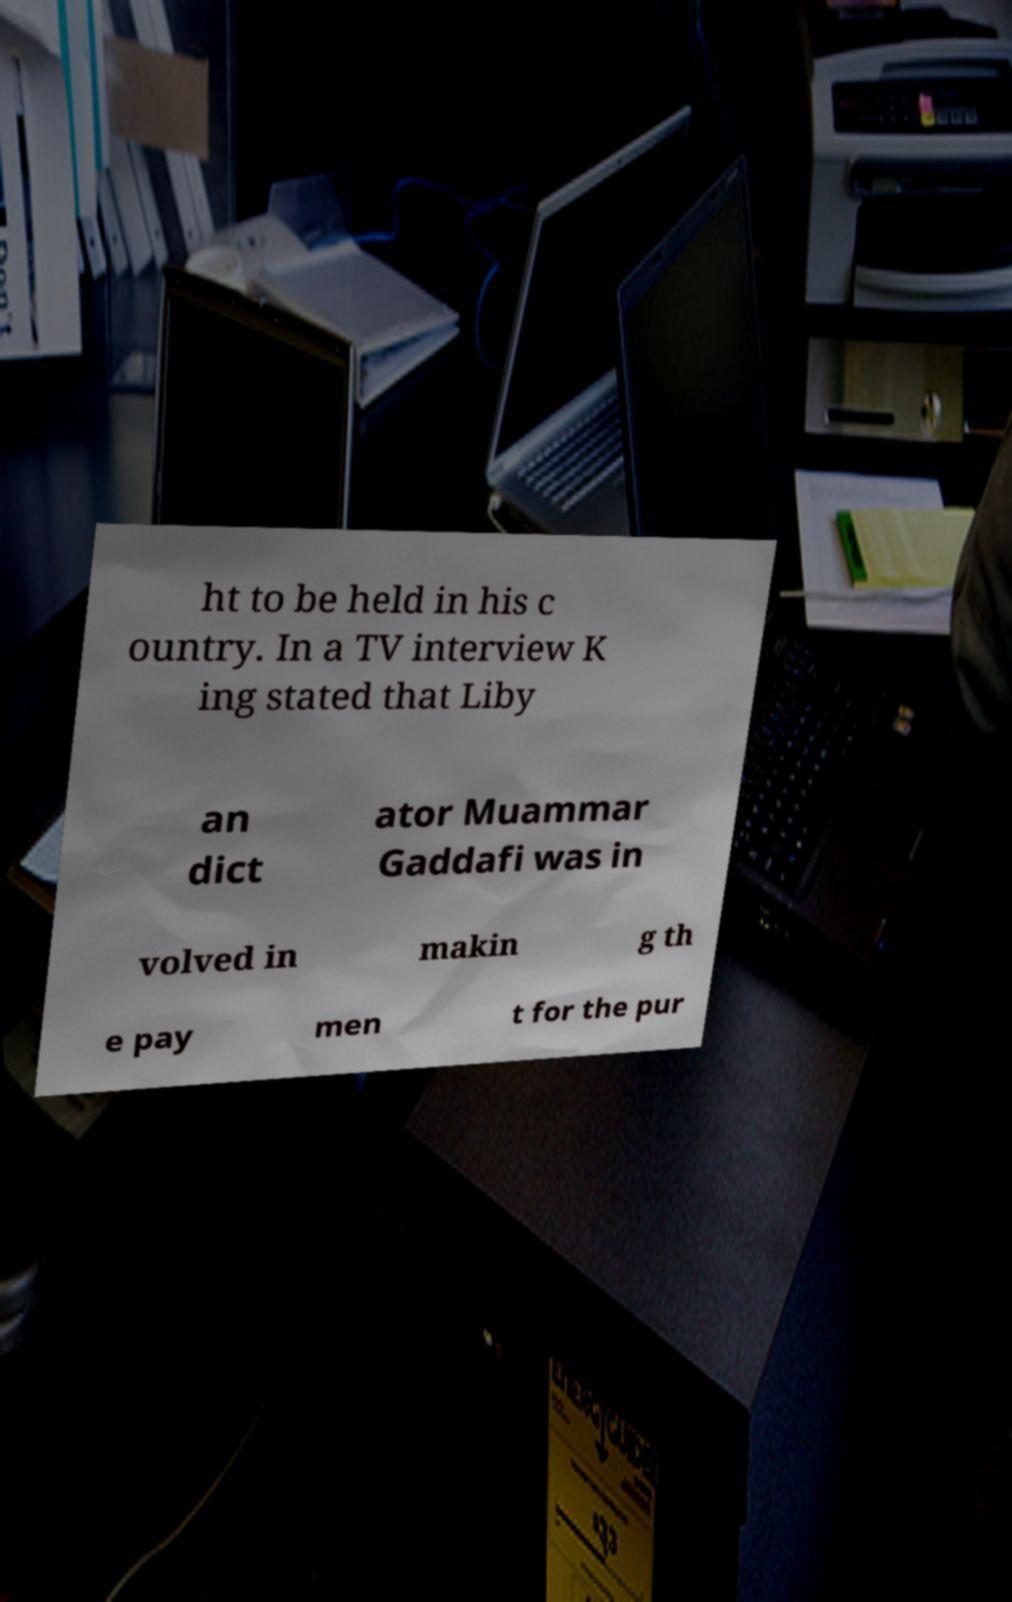Could you extract and type out the text from this image? ht to be held in his c ountry. In a TV interview K ing stated that Liby an dict ator Muammar Gaddafi was in volved in makin g th e pay men t for the pur 